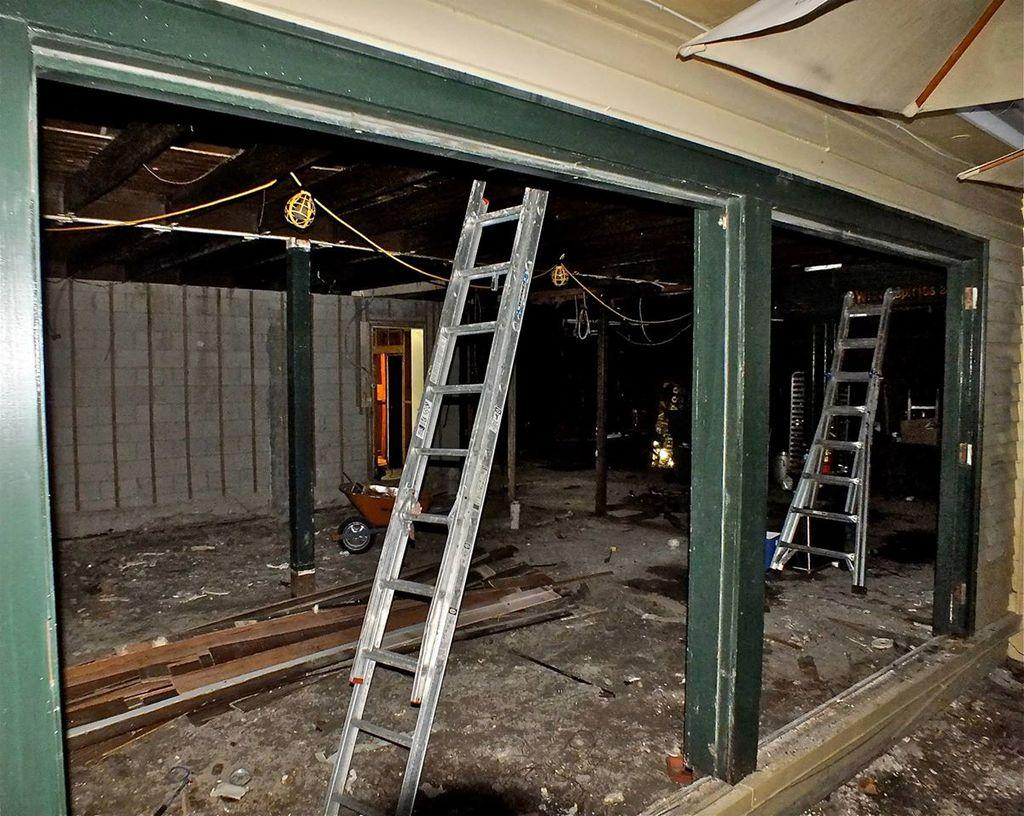What type of vehicle is present in the image? There is a trolley in the image. What material is used for the planks in the image? The planks in the image are made of wood. What type of equipment is visible in the image? There are ladders in the image. Where are the objects located in the image? The objects are on the land. What is attached to the wall in the image? There is a wooden frame on the wall in the image. What object can be seen in the top right corner of the image? There is an umbrella in the top right corner of the image. What type of manager is depicted in the image? There is no manager present in the image. What type of oatmeal is being served in the image? There is no oatmeal present in the image. 